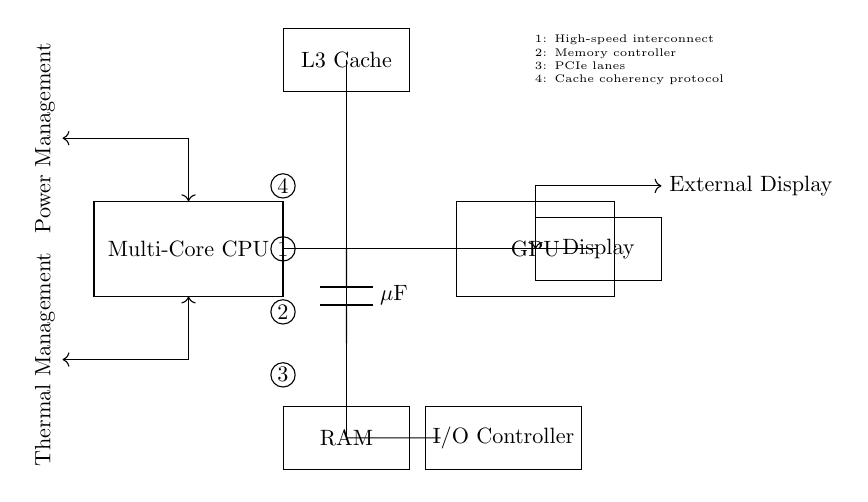What is the main component of this circuit? The main component is the Multi-Core CPU, which processes and executes instructions. It is depicted prominently in the center of the diagram.
Answer: Multi-Core CPU What does the bus connect to? The bus connects to the RAM, L3 Cache, and GPU, facilitating communication among these essential components.
Answer: RAM, L3 Cache, GPU How many power management connections are shown? There are two connections labeled for power management, one at the north and another at the south, indicating its dual role in the circuit.
Answer: 2 What type of controller is present in this circuit? The I/O Controller is represented in the circuit, managing input and output operations.
Answer: I/O Controller What does the label above the bus indicate? The label above the bus indicates that it represents high-speed interconnect, which is crucial for fast communication between components.
Answer: High-speed interconnect Which component manages thermal aspects? The Multi-Core CPU has a thermal management connection, highlighting the importance of temperature regulation in processing performance.
Answer: Multi-Core CPU What is indicated by the label next to PCIe lanes? The label next to PCIe lanes indicates a cache coherency protocol, which is essential for maintaining data consistency among caches in multi-core processors.
Answer: Cache coherency protocol 